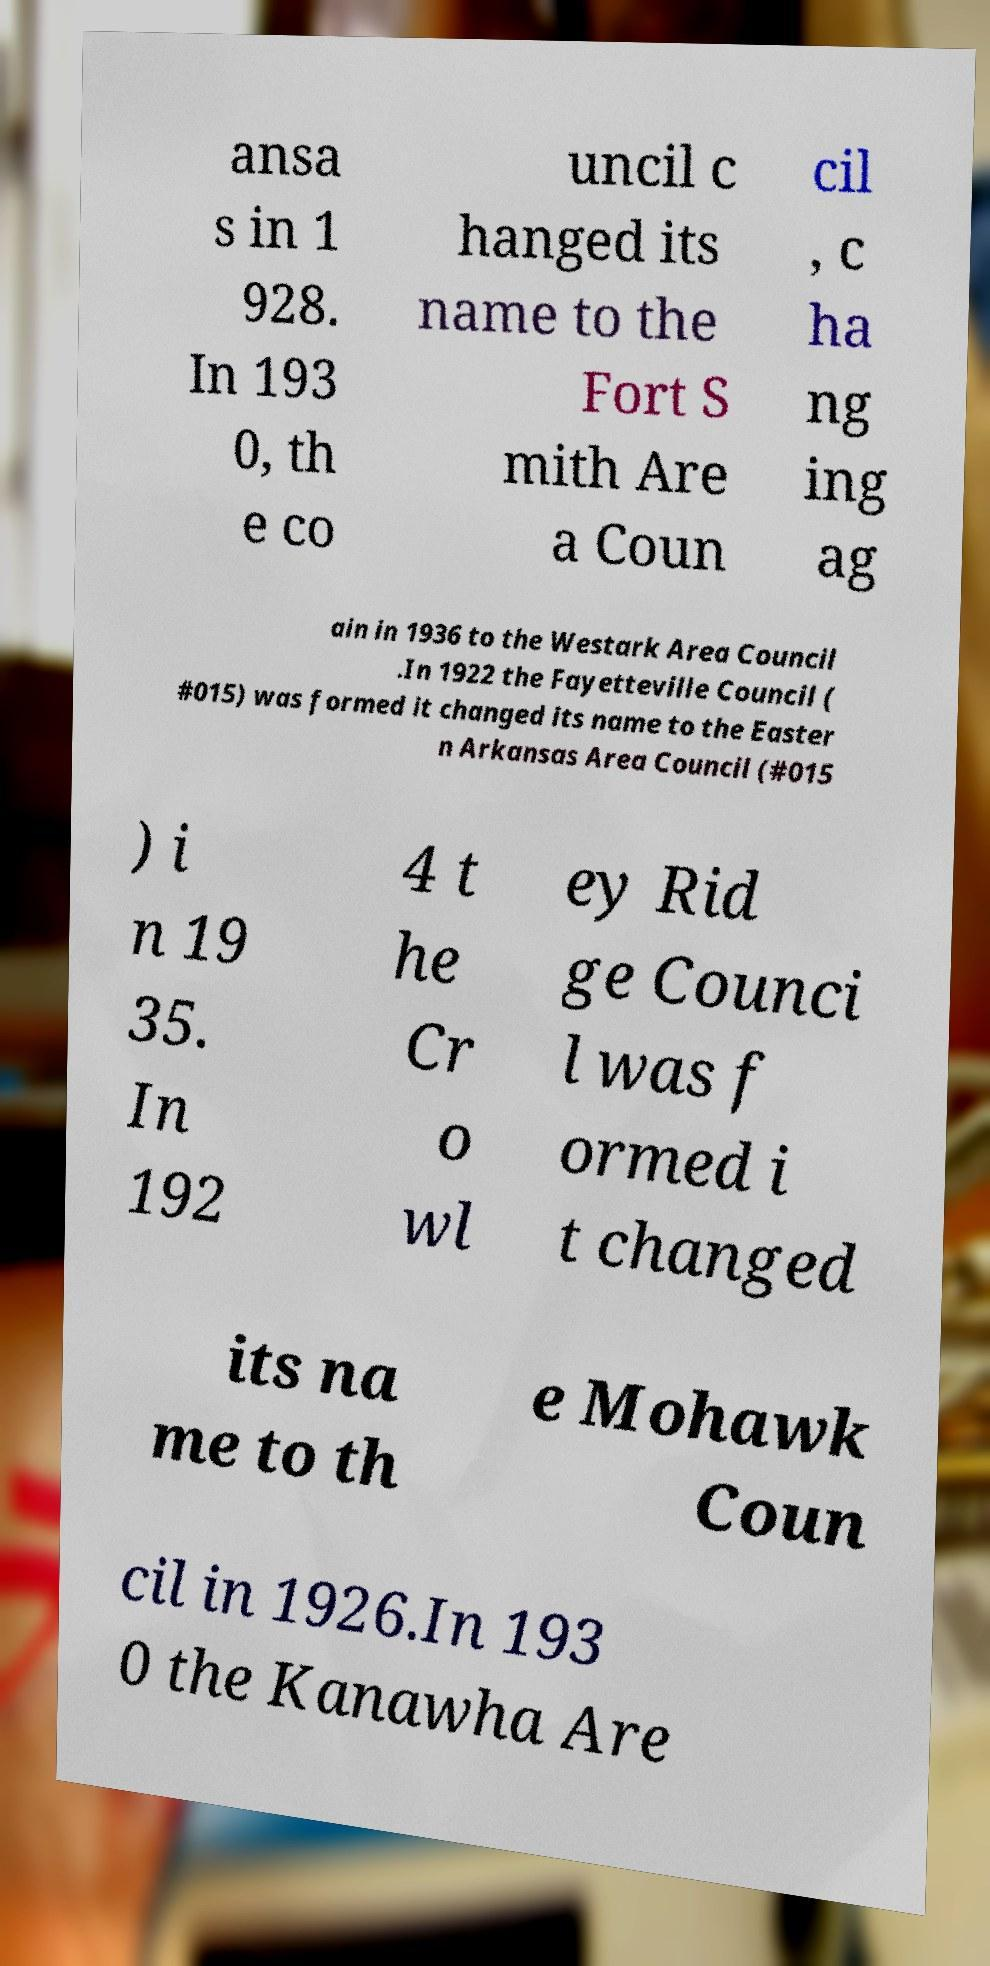There's text embedded in this image that I need extracted. Can you transcribe it verbatim? ansa s in 1 928. In 193 0, th e co uncil c hanged its name to the Fort S mith Are a Coun cil , c ha ng ing ag ain in 1936 to the Westark Area Council .In 1922 the Fayetteville Council ( #015) was formed it changed its name to the Easter n Arkansas Area Council (#015 ) i n 19 35. In 192 4 t he Cr o wl ey Rid ge Counci l was f ormed i t changed its na me to th e Mohawk Coun cil in 1926.In 193 0 the Kanawha Are 